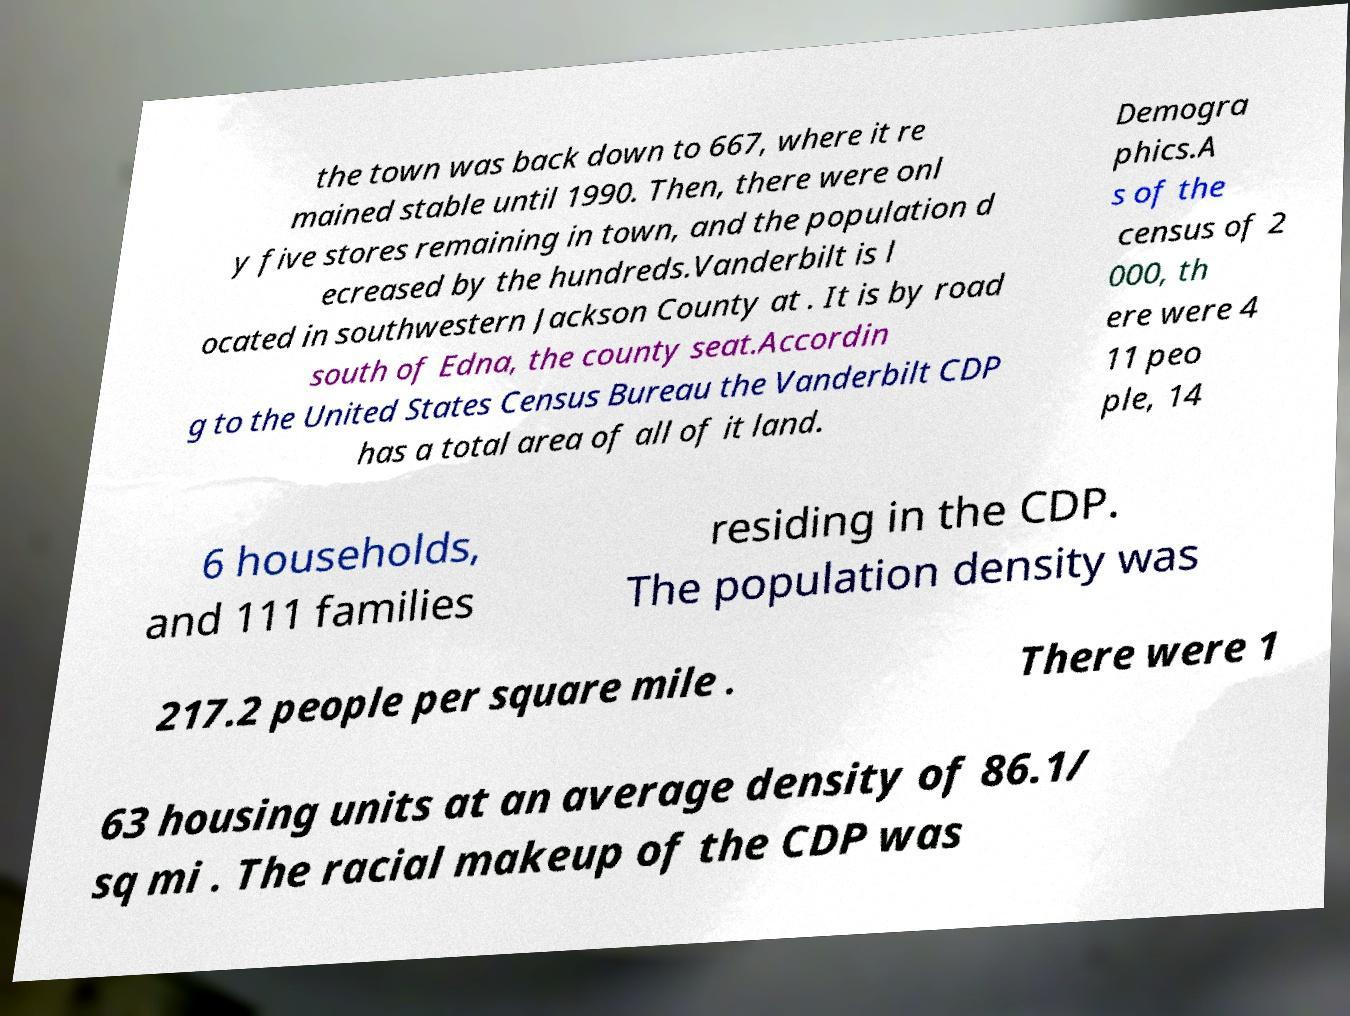Please read and relay the text visible in this image. What does it say? the town was back down to 667, where it re mained stable until 1990. Then, there were onl y five stores remaining in town, and the population d ecreased by the hundreds.Vanderbilt is l ocated in southwestern Jackson County at . It is by road south of Edna, the county seat.Accordin g to the United States Census Bureau the Vanderbilt CDP has a total area of all of it land. Demogra phics.A s of the census of 2 000, th ere were 4 11 peo ple, 14 6 households, and 111 families residing in the CDP. The population density was 217.2 people per square mile . There were 1 63 housing units at an average density of 86.1/ sq mi . The racial makeup of the CDP was 